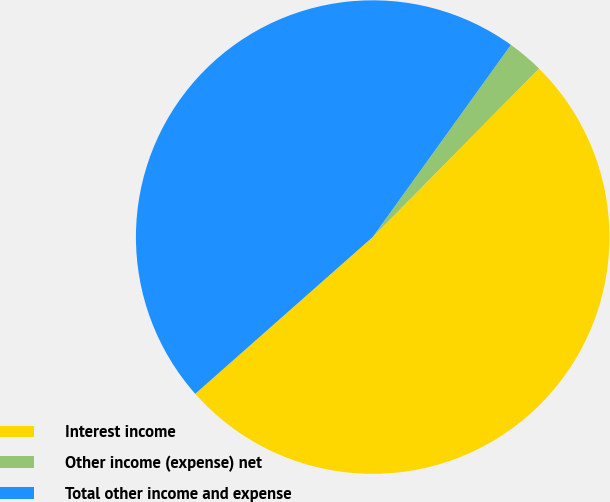Convert chart. <chart><loc_0><loc_0><loc_500><loc_500><pie_chart><fcel>Interest income<fcel>Other income (expense) net<fcel>Total other income and expense<nl><fcel>51.09%<fcel>2.47%<fcel>46.44%<nl></chart> 